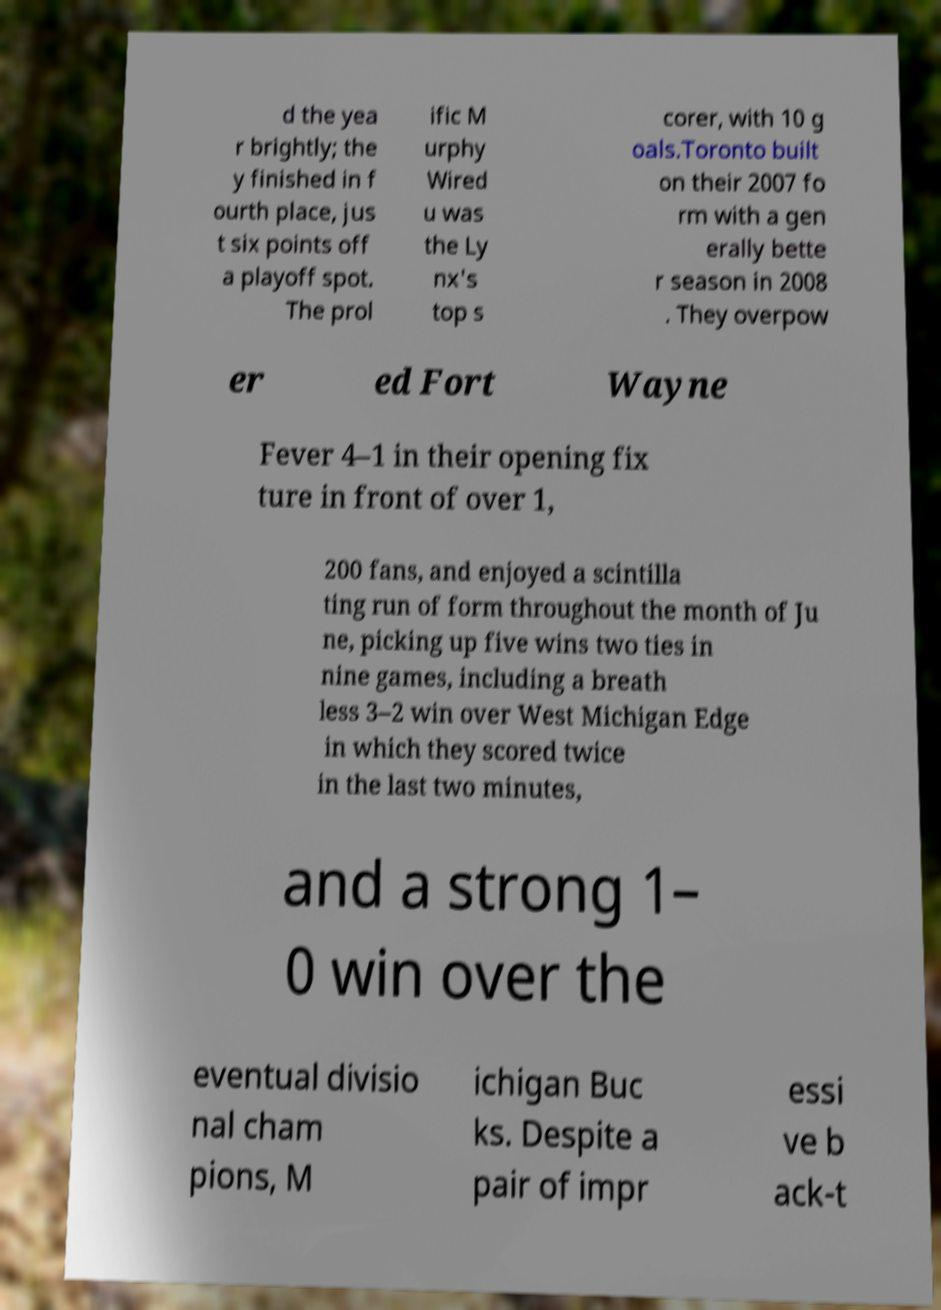Please identify and transcribe the text found in this image. d the yea r brightly; the y finished in f ourth place, jus t six points off a playoff spot. The prol ific M urphy Wired u was the Ly nx's top s corer, with 10 g oals.Toronto built on their 2007 fo rm with a gen erally bette r season in 2008 . They overpow er ed Fort Wayne Fever 4–1 in their opening fix ture in front of over 1, 200 fans, and enjoyed a scintilla ting run of form throughout the month of Ju ne, picking up five wins two ties in nine games, including a breath less 3–2 win over West Michigan Edge in which they scored twice in the last two minutes, and a strong 1– 0 win over the eventual divisio nal cham pions, M ichigan Buc ks. Despite a pair of impr essi ve b ack-t 